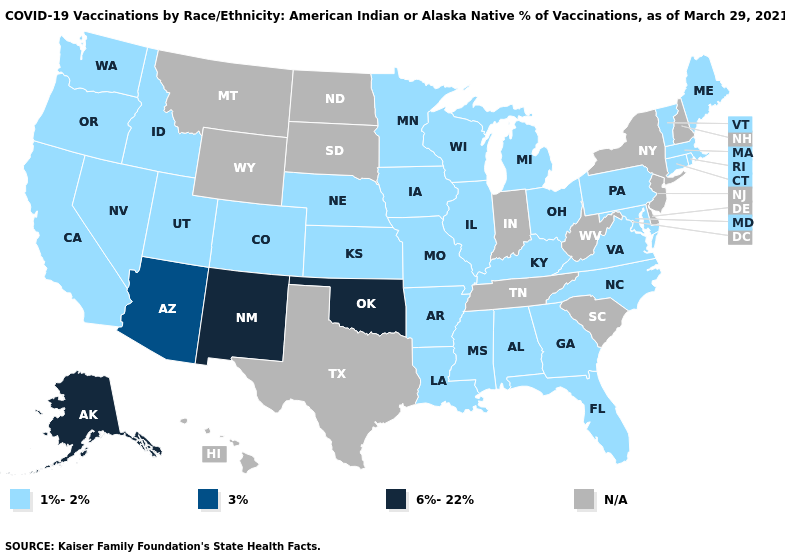What is the value of California?
Keep it brief. 1%-2%. Does Kentucky have the highest value in the USA?
Be succinct. No. What is the lowest value in the USA?
Write a very short answer. 1%-2%. Does New Mexico have the highest value in the USA?
Be succinct. Yes. Name the states that have a value in the range 1%-2%?
Quick response, please. Alabama, Arkansas, California, Colorado, Connecticut, Florida, Georgia, Idaho, Illinois, Iowa, Kansas, Kentucky, Louisiana, Maine, Maryland, Massachusetts, Michigan, Minnesota, Mississippi, Missouri, Nebraska, Nevada, North Carolina, Ohio, Oregon, Pennsylvania, Rhode Island, Utah, Vermont, Virginia, Washington, Wisconsin. Name the states that have a value in the range 3%?
Concise answer only. Arizona. What is the value of Hawaii?
Concise answer only. N/A. What is the lowest value in the West?
Answer briefly. 1%-2%. What is the value of Delaware?
Concise answer only. N/A. What is the lowest value in the USA?
Short answer required. 1%-2%. What is the lowest value in states that border Illinois?
Write a very short answer. 1%-2%. Which states have the highest value in the USA?
Answer briefly. Alaska, New Mexico, Oklahoma. Name the states that have a value in the range 1%-2%?
Write a very short answer. Alabama, Arkansas, California, Colorado, Connecticut, Florida, Georgia, Idaho, Illinois, Iowa, Kansas, Kentucky, Louisiana, Maine, Maryland, Massachusetts, Michigan, Minnesota, Mississippi, Missouri, Nebraska, Nevada, North Carolina, Ohio, Oregon, Pennsylvania, Rhode Island, Utah, Vermont, Virginia, Washington, Wisconsin. What is the highest value in the MidWest ?
Be succinct. 1%-2%. 